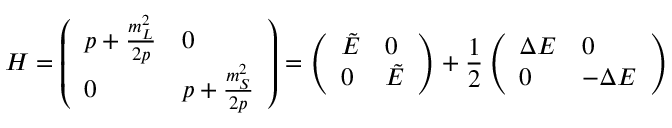Convert formula to latex. <formula><loc_0><loc_0><loc_500><loc_500>H = \left ( \begin{array} { l l } { { p + \frac { m _ { L } ^ { 2 } } { 2 p } } } & { 0 } \\ { 0 } & { { p + \frac { m _ { S } ^ { 2 } } { 2 p } } } \end{array} \right ) = \left ( \begin{array} { l l } { { \tilde { E } } } & { 0 } \\ { 0 } & { { \tilde { E } } } \end{array} \right ) + { \frac { 1 } { 2 } } \left ( \begin{array} { l l } { \Delta E } & { 0 } \\ { 0 } & { - \Delta E } \end{array} \right )</formula> 